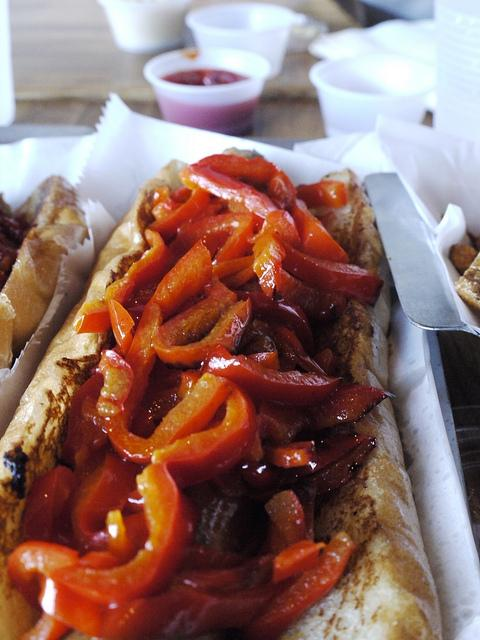What is on top of the sandwich? peppers 